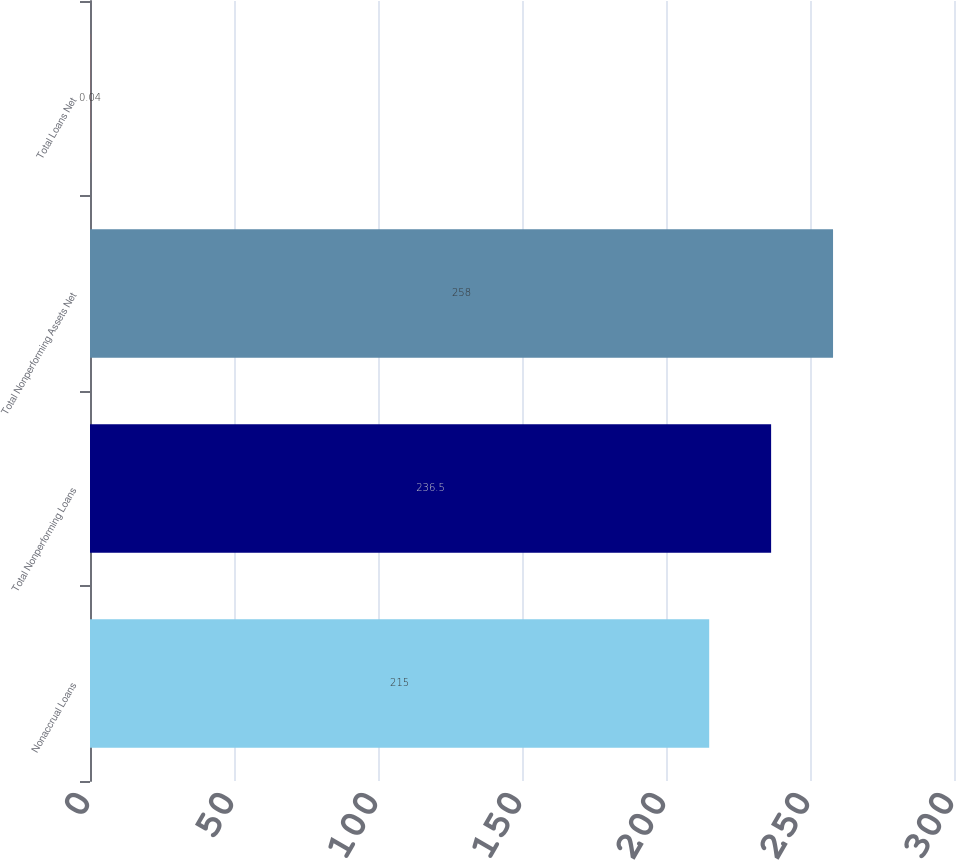<chart> <loc_0><loc_0><loc_500><loc_500><bar_chart><fcel>Nonaccrual Loans<fcel>Total Nonperforming Loans<fcel>Total Nonperforming Assets Net<fcel>Total Loans Net<nl><fcel>215<fcel>236.5<fcel>258<fcel>0.04<nl></chart> 